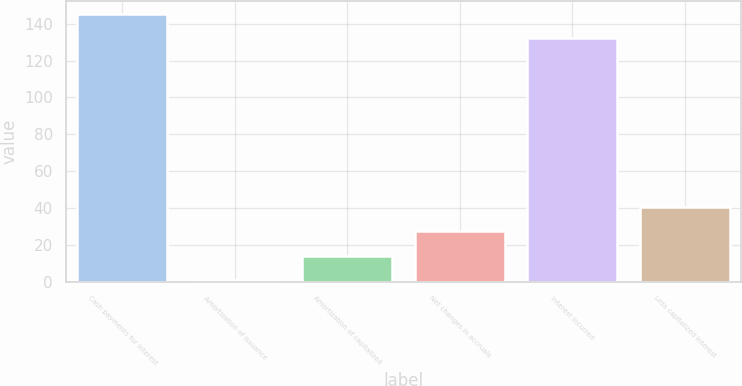<chart> <loc_0><loc_0><loc_500><loc_500><bar_chart><fcel>Cash payments for interest<fcel>Amortization of issuance<fcel>Amortization of capitalized<fcel>Net changes in accruals<fcel>Interest incurred<fcel>Less capitalized interest<nl><fcel>145.2<fcel>1<fcel>14.2<fcel>27.4<fcel>132<fcel>40.6<nl></chart> 